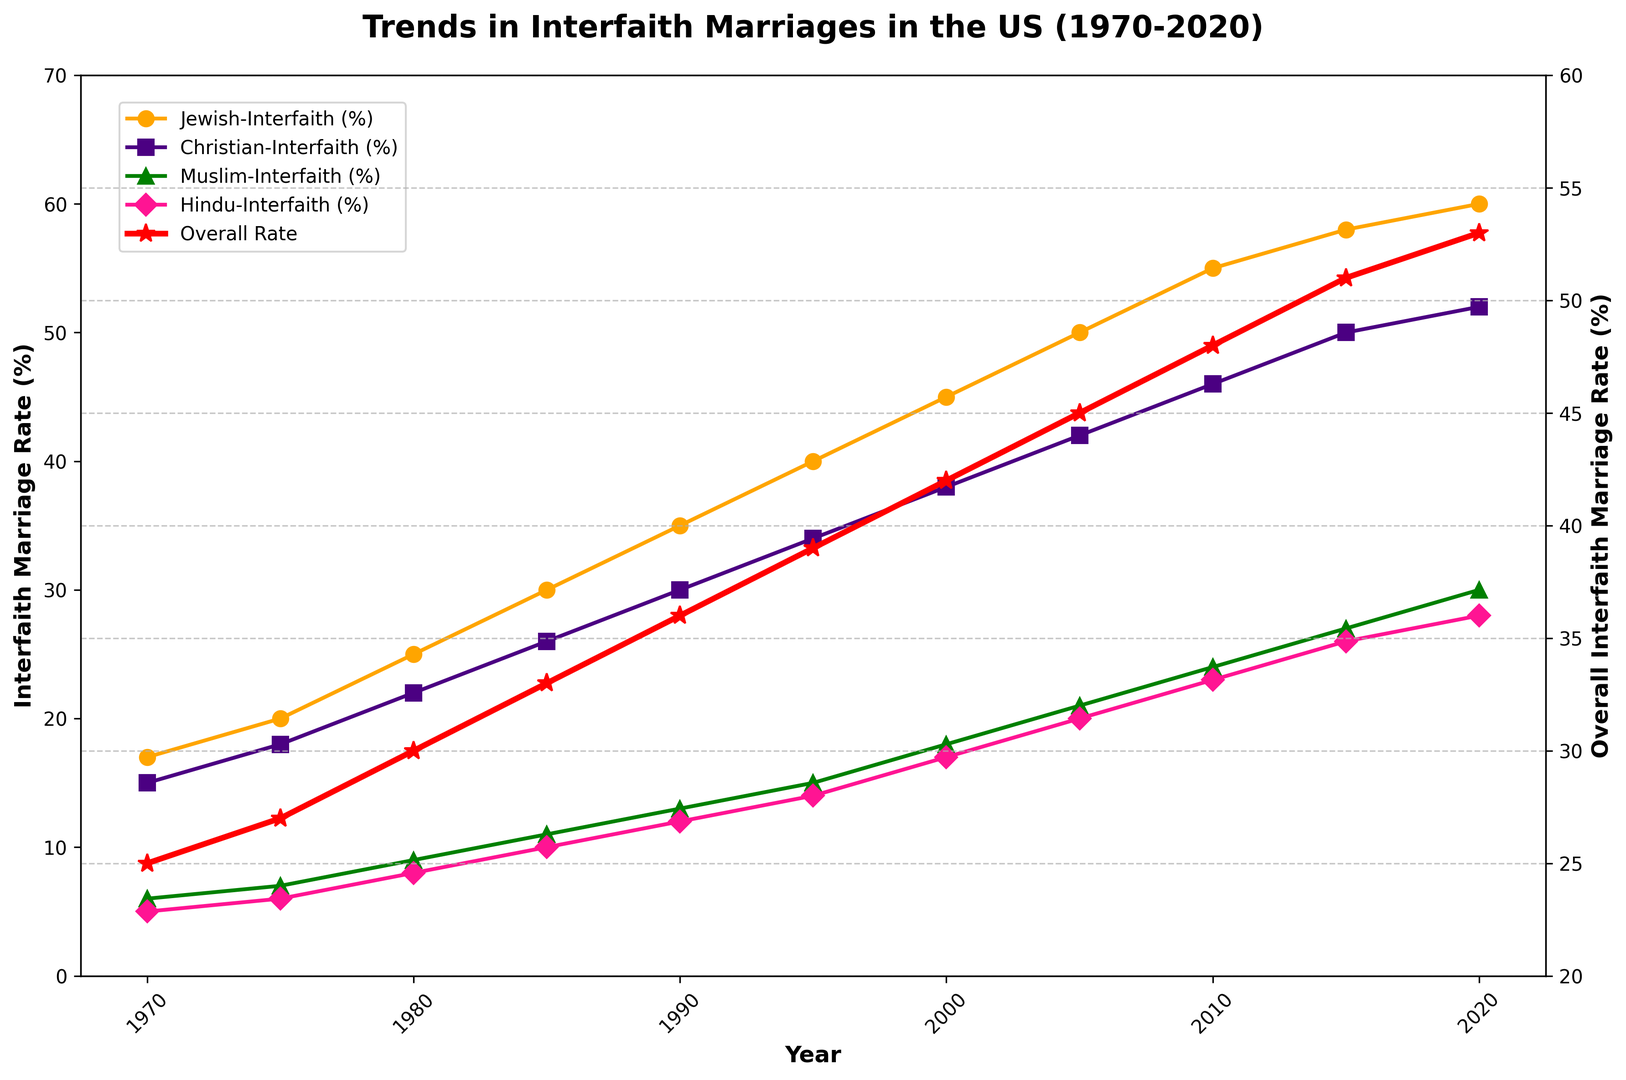what is the overall trend in the Jewish interfaith marriage rate from 1970 to 2020? The Jewish interfaith marriage rate shows a steady increase from 17% in 1970 to 60% in 2020.
Answer: Rising trend In which year did the Christian interfaith marriage rate surpass 40%? Looking at the plot for the Christian interfaith marriage rate, the rate surpassed 40% in 2005.
Answer: 2005 How does the Muslim interfaith marriage rate in 2010 compare to that in 1975? The Muslim interfaith marriage rate in 2010 is 24%, whereas in 1975 it was 7%. Therefore, the rate has significantly increased.
Answer: Increased significantly Which religious group had the lowest interfaith marriage rate in 2020? The Hindu interfaith marriage rate was the lowest at 28% in 2020.
Answer: Hindu What's the overall interfaith marriage rate trend from 1970 to 2020? The overall interfaith marriage rate steadily increases from 25% in 1970 to 53% in 2020.
Answer: Rising trend By how many percentage points did the Hindu interfaith marriage rate increase from 1980 to 2015? The Hindu interfaith marriage rate increased from 8% in 1980 to 26% in 2015. Thus, it increased by 18 percentage points (26 - 8 = 18).
Answer: 18 percentage points Comparing 1990 and 2020, which group saw the highest increase in their interfaith marriage rate? Between 1990 and 2020, the Jewish group's interfaith marriage rate increased from 35% to 60%, showing an increase of 25 percentage points. Other groups had smaller increases.
Answer: Jewish What is the key difference in trends between the specific religious groups' interfaith marriage rates and the overall interfaith marriage rate? Specific religious groups' interfaith marriage rates show steeper increases compared to the overall interfaith marriage rate.
Answer: Steeper increases in specific groups Between which years did the overall interfaith marriage rate see the largest increase? The largest increase in the overall interfaith marriage rate occurred between 2000 and 2005, increasing from 42% to 45%.
Answer: 2000-2005 